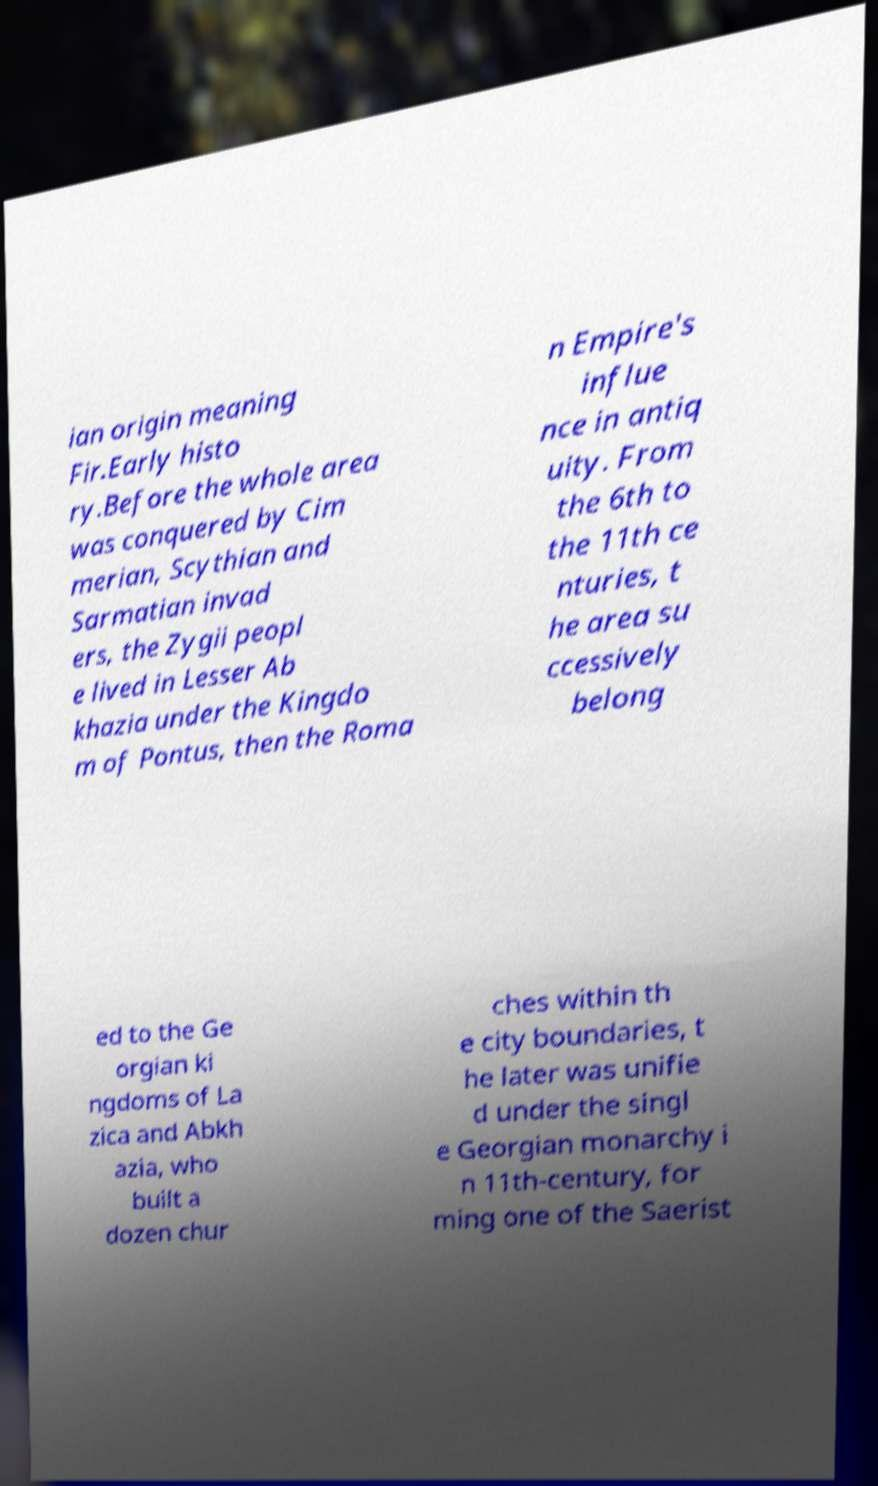Please identify and transcribe the text found in this image. ian origin meaning Fir.Early histo ry.Before the whole area was conquered by Cim merian, Scythian and Sarmatian invad ers, the Zygii peopl e lived in Lesser Ab khazia under the Kingdo m of Pontus, then the Roma n Empire's influe nce in antiq uity. From the 6th to the 11th ce nturies, t he area su ccessively belong ed to the Ge orgian ki ngdoms of La zica and Abkh azia, who built a dozen chur ches within th e city boundaries, t he later was unifie d under the singl e Georgian monarchy i n 11th-century, for ming one of the Saerist 